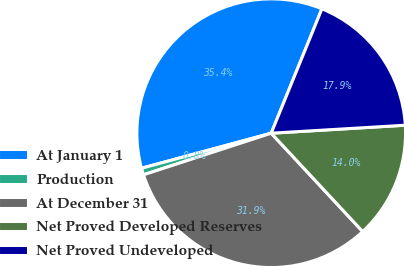<chart> <loc_0><loc_0><loc_500><loc_500><pie_chart><fcel>At January 1<fcel>Production<fcel>At December 31<fcel>Net Proved Developed Reserves<fcel>Net Proved Undeveloped<nl><fcel>35.36%<fcel>0.81%<fcel>31.91%<fcel>14.02%<fcel>17.89%<nl></chart> 